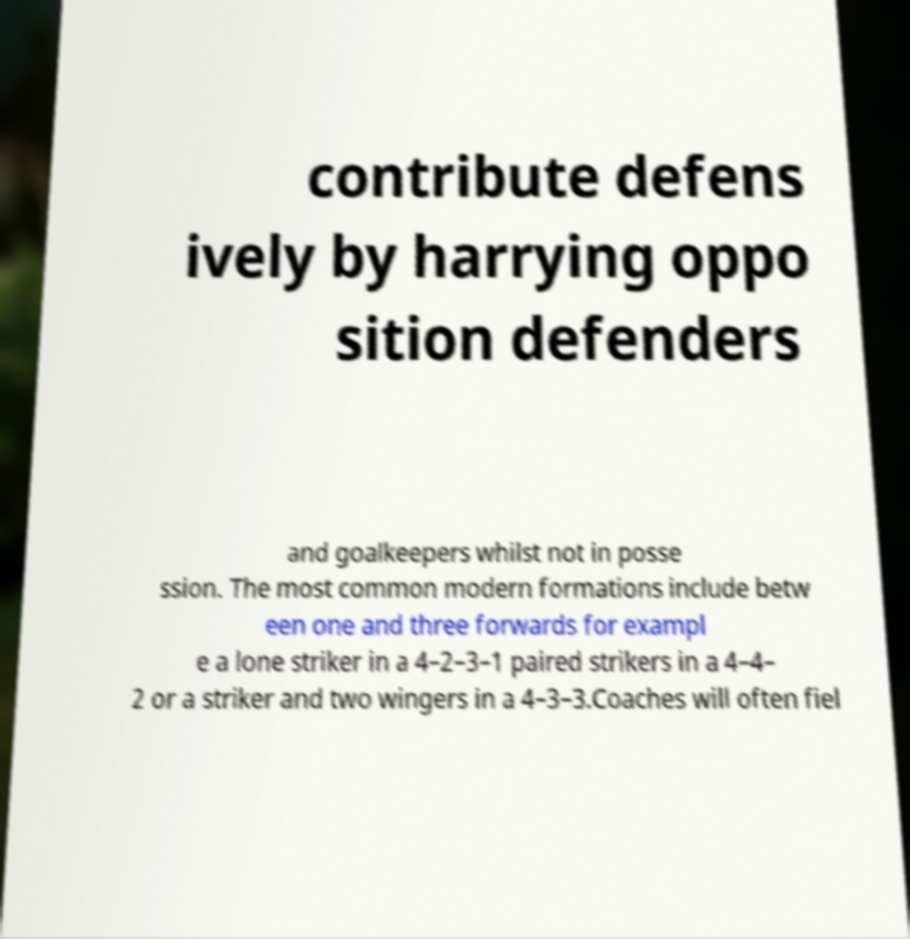I need the written content from this picture converted into text. Can you do that? contribute defens ively by harrying oppo sition defenders and goalkeepers whilst not in posse ssion. The most common modern formations include betw een one and three forwards for exampl e a lone striker in a 4–2–3–1 paired strikers in a 4–4– 2 or a striker and two wingers in a 4–3–3.Coaches will often fiel 